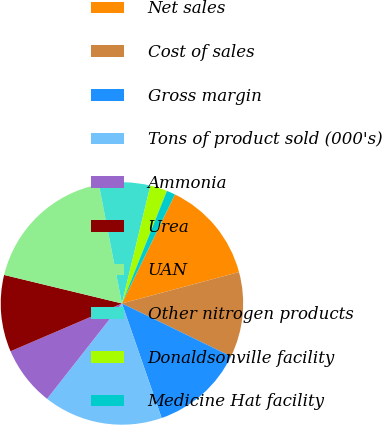Convert chart. <chart><loc_0><loc_0><loc_500><loc_500><pie_chart><fcel>Net sales<fcel>Cost of sales<fcel>Gross margin<fcel>Tons of product sold (000's)<fcel>Ammonia<fcel>Urea<fcel>UAN<fcel>Other nitrogen products<fcel>Donaldsonville facility<fcel>Medicine Hat facility<nl><fcel>13.63%<fcel>11.36%<fcel>12.5%<fcel>15.9%<fcel>7.96%<fcel>10.23%<fcel>18.17%<fcel>6.82%<fcel>2.28%<fcel>1.15%<nl></chart> 